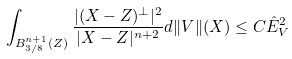<formula> <loc_0><loc_0><loc_500><loc_500>\int _ { B ^ { n + 1 } _ { 3 / 8 } ( Z ) } \frac { | ( X - Z ) ^ { \perp } | ^ { 2 } } { | X - Z | ^ { n + 2 } } d \| V \| ( X ) \leq C { \hat { E } } _ { V } ^ { 2 }</formula> 